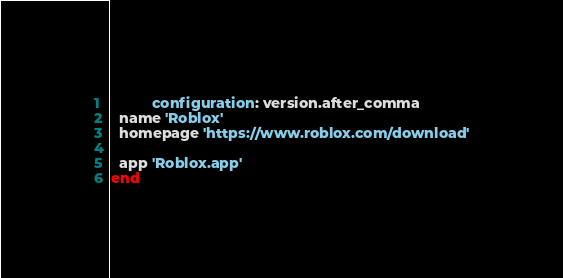Convert code to text. <code><loc_0><loc_0><loc_500><loc_500><_Ruby_>          configuration: version.after_comma
  name 'Roblox'
  homepage 'https://www.roblox.com/download'

  app 'Roblox.app'
end
</code> 